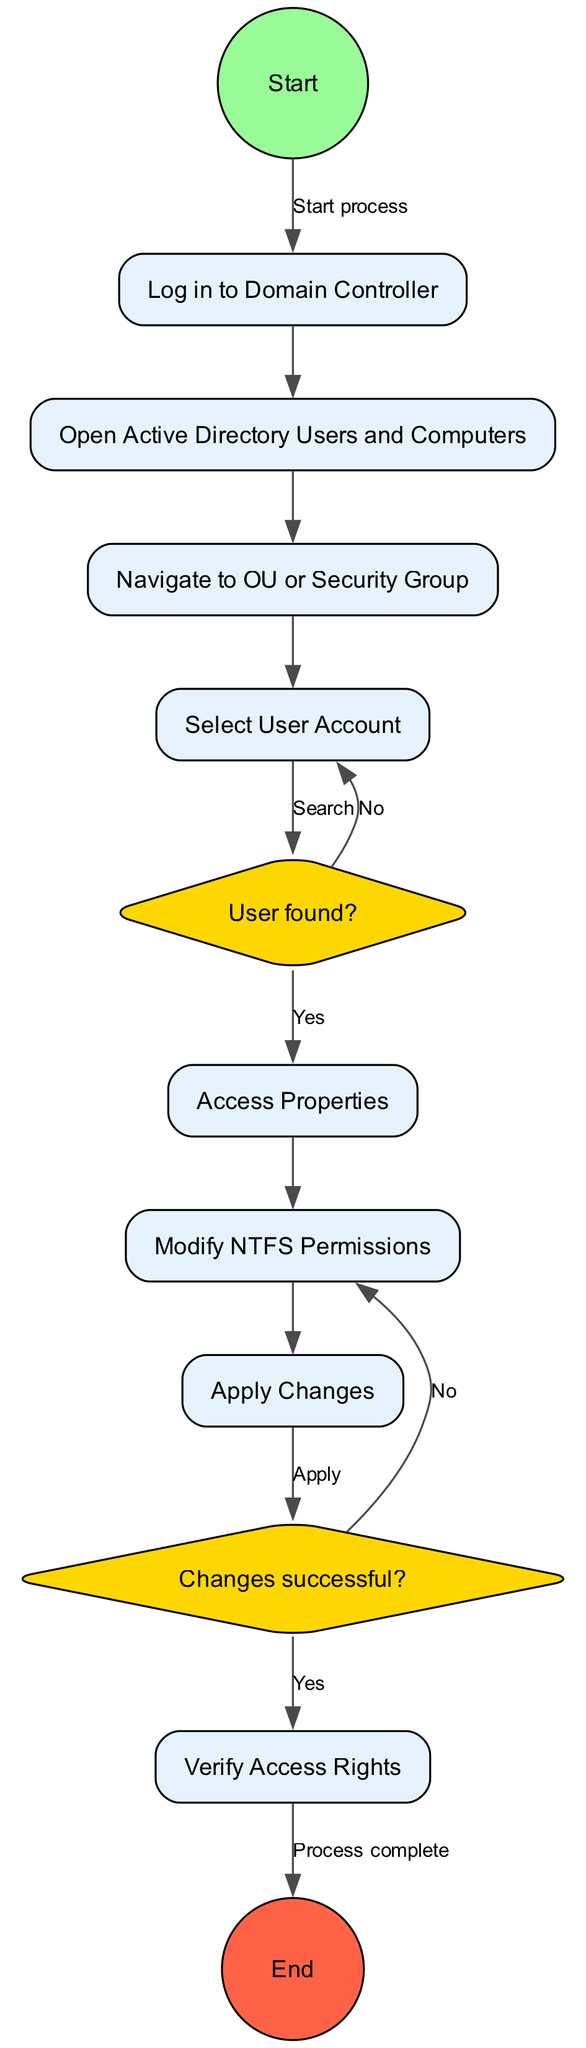What is the first activity in the diagram? The first activity connects directly to the start node, labeled as "Log in to Domain Controller."
Answer: Log in to Domain Controller How many activities are present in the diagram? The diagram includes a total of seven activities listed, demonstrating the steps in user access rights management.
Answer: 7 What happens if the user is not found? If the user is not found, the diagram indicates that the process leads to the option "Search for User."
Answer: Search for User What is the last action taken in the process? The process concludes with the action labeled "Verify Access Rights," just before reaching the end node.
Answer: Verify Access Rights Which decision requires troubleshooting permissions? The decision addressing whether changes were successful leads to "Troubleshoot Permissions" if no changes were applied successfully.
Answer: Troubleshoot Permissions If a user is found, which activity follows? If the user is found, the next activity proceeding from "Access Properties" is "Modify NTFS Permissions."
Answer: Modify NTFS Permissions What color represents the decision nodes? The decision nodes in the diagram are filled with a golden color, indicating their unique function in the flow.
Answer: Golden How many edges are entering the "Verify Access Rights"? There are two edges entering the "Verify Access Rights" node – one from applying changes success and one from troubleshooting if changes fail.
Answer: 2 What does the decision "User found?" evaluate? The decision "User found?" evaluates whether the user account specified in the process can be located, leading to two possible actions based on the outcome.
Answer: User account location 